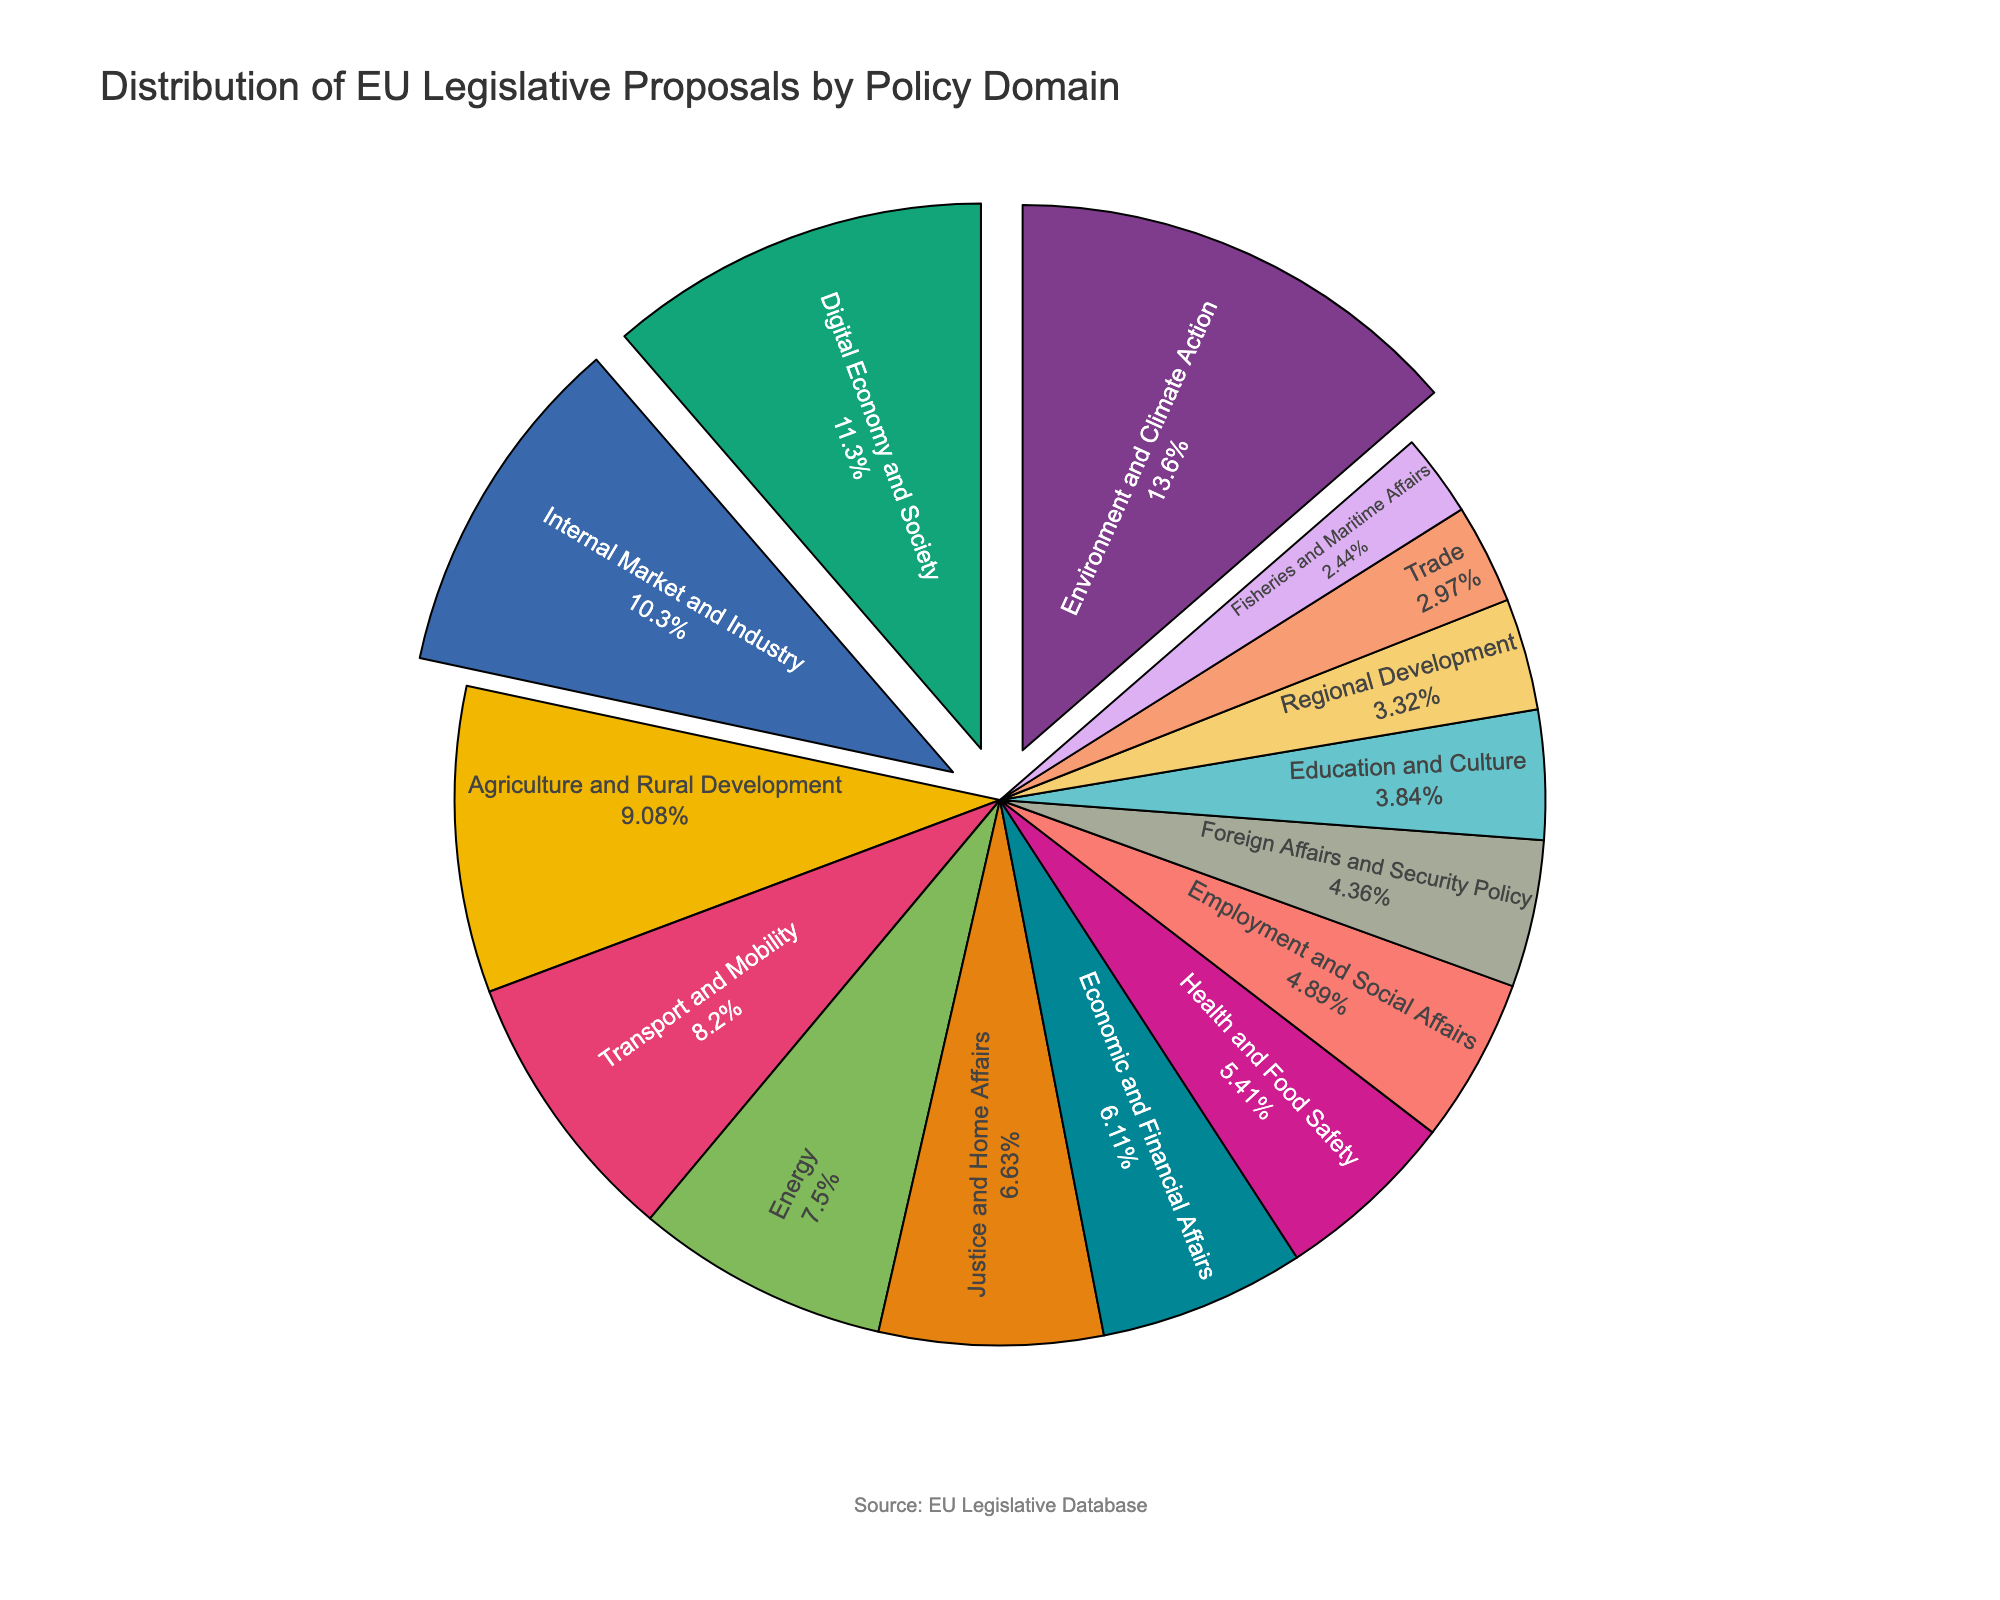What are the top three policy domains by the number of proposals? To find the top three policy domains, identify the three largest sectors of the pie chart. The largest sector is Environment and Climate Action, followed by Digital Economy and Society, and Internal Market and Industry.
Answer: Environment and Climate Action, Digital Economy and Society, Internal Market and Industry Which policy domain has fewer proposals, Energy or Transport and Mobility? Compare the sizes of the pie chart segments for Energy and Transport and Mobility. Energy has 43 proposals, while Transport and Mobility has 47 proposals.
Answer: Energy How many more proposals does Environment and Climate Action have compared to Foreign Affairs and Security Policy? Subtract the number of proposals for Foreign Affairs and Security Policy from Environment and Climate Action. Environment and Climate Action has 78 proposals, and Foreign Affairs and Security Policy has 25. The difference is 78 - 25 = 53.
Answer: 53 What percentage of the total proposals does Agriculture and Rural Development represent? Calculate the percentage by dividing the number of proposals for Agriculture and Rural Development by the total number of proposals and then multiplying by 100. The total is 573. So, (52 / 573) * 100 = 9.08%.
Answer: 9.08% Which is larger, the proportion of Health and Food Safety or Education and Culture proposals? Compare the sizes of the pie chart segments for Health and Food Safety and Education and Culture. Health and Food Safety has 31 proposals, while Education and Culture has 22. Thus, Health and Food Safety has a larger proportion.
Answer: Health and Food Safety If you combine the proposals for Justice and Home Affairs and Economic and Financial Affairs, what is the total number of proposals? Add the number of proposals for Justice and Home Affairs and Economic and Financial Affairs. Justice and Home Affairs has 38 proposals, and Economic and Financial Affairs has 35 proposals. The total is 38 + 35 = 73.
Answer: 73 By how many proposals does Digital Economy and Society exceed Employment and Social Affairs? Subtract the number of proposals for Employment and Social Affairs from Digital Economy and Society. Digital Economy and Society has 65 proposals, and Employment and Social Affairs has 28. The difference is 65 - 28 = 37.
Answer: 37 Which has a greater percentage of the total proposals: Fisheries and Maritime Affairs or Trade? Compare the number of proposals for Fisheries and Maritime Affairs and Trade and calculate their percentages of the total. Fisheries and Maritime Affairs has 14 proposals, and Trade has 17 proposals. Their percentages are (14/573)*100 ≈ 2.44% and (17/573)*100 ≈ 2.97%, respectively. Trade has a greater percentage.
Answer: Trade What is the combined percentage of the proposals for Environment and Climate Action and Digital Economy and Society? Calculate the percentage for each, then sum them. Environment and Climate Action has 78 proposals, and Digital Economy and Society has 65 proposals. Their combined percentage is ((78+65)/573) * 100 ≈ 25.05%.
Answer: 25.05% 